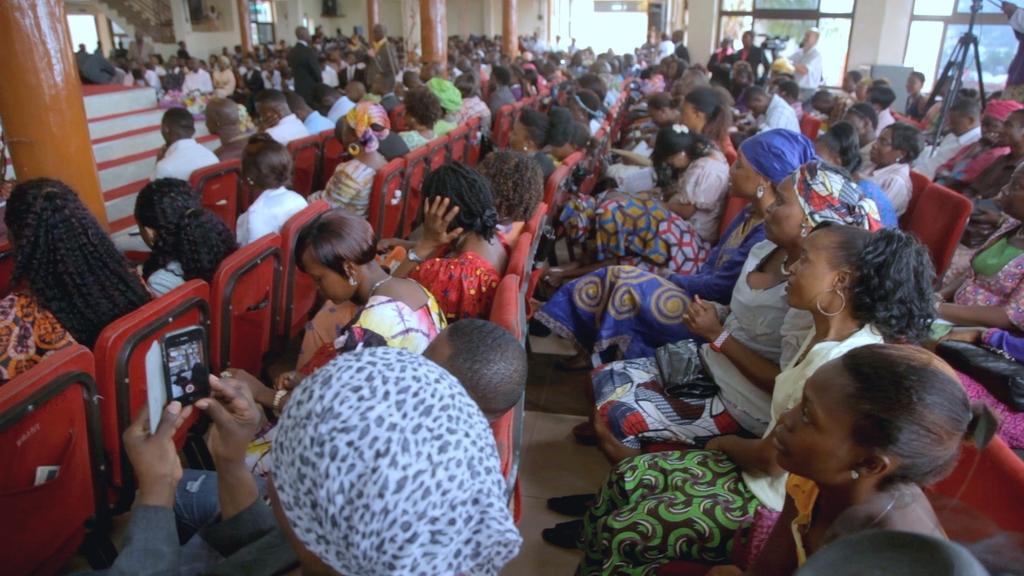Please provide a concise description of this image. In the image there are many people sitting on chairs, this is clicked inside a building, in the back there are few men holding cameras, on the left side there are steps beside the pillars. 